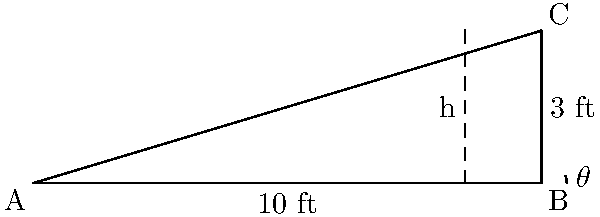As a cat groomer, you're setting up a new grooming table for your YouTube video. The sun casts a shadow of the table that extends 10 feet from its base. If the angle of elevation from the end of the shadow to the top of the table is $\theta$, where $\tan(\theta) = \frac{3}{10}$, what is the height of the grooming table? Let's approach this step-by-step:

1) We're given that $\tan(\theta) = \frac{3}{10}$. This means that for every 10 units of horizontal distance, there are 3 units of vertical distance.

2) In our case, the horizontal distance (the shadow) is 10 feet.

3) We can set up the following equation:

   $\tan(\theta) = \frac{\text{height}}{\text{shadow length}} = \frac{h}{10}$

4) We know that $\tan(\theta) = \frac{3}{10}$, so we can substitute this:

   $\frac{3}{10} = \frac{h}{10}$

5) To solve for $h$, we can cross-multiply:

   $3 \cdot 10 = 10h$

6) Simplify:

   $30 = 10h$

7) Divide both sides by 10:

   $3 = h$

Therefore, the height of the grooming table is 3 feet.
Answer: 3 feet 